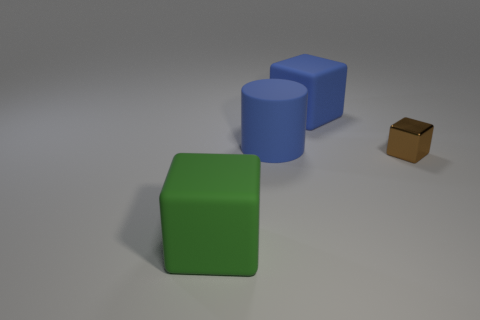Add 4 cylinders. How many objects exist? 8 Subtract all cylinders. How many objects are left? 3 Subtract 1 blue blocks. How many objects are left? 3 Subtract all tiny brown matte blocks. Subtract all tiny brown shiny objects. How many objects are left? 3 Add 1 large green things. How many large green things are left? 2 Add 4 big cubes. How many big cubes exist? 6 